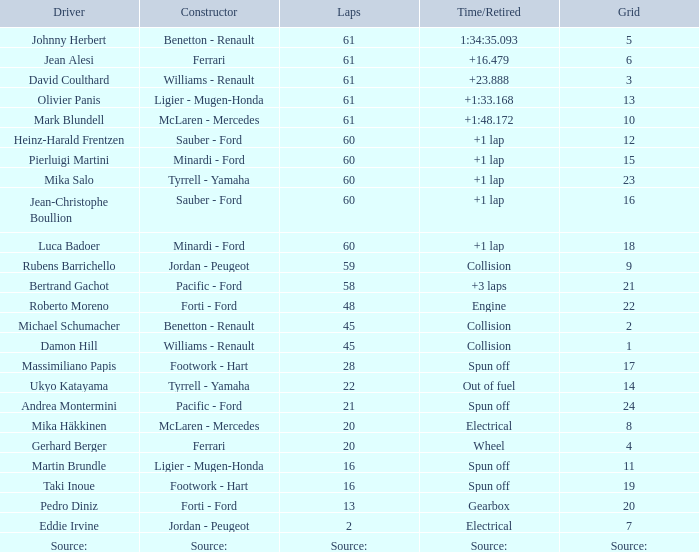What is the count of laps that luca badoer has done? 60.0. 